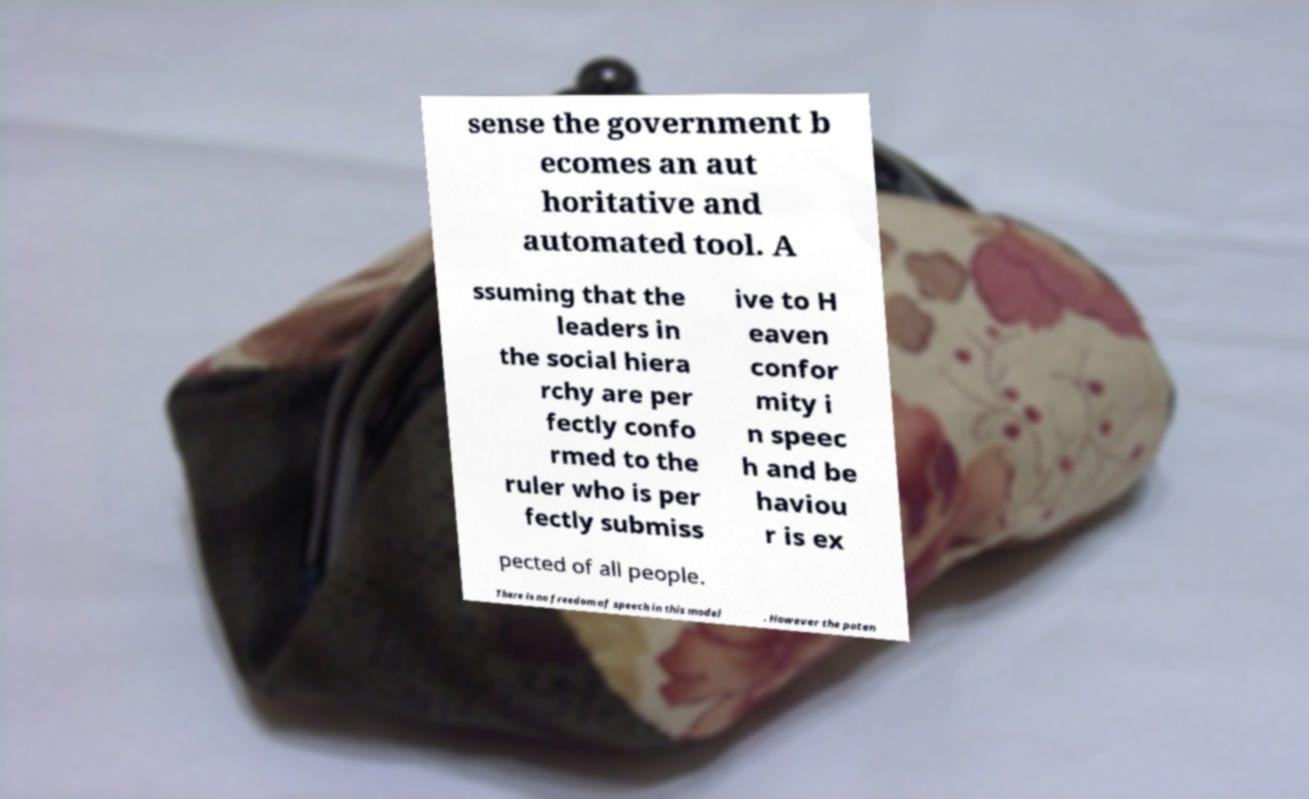Could you assist in decoding the text presented in this image and type it out clearly? sense the government b ecomes an aut horitative and automated tool. A ssuming that the leaders in the social hiera rchy are per fectly confo rmed to the ruler who is per fectly submiss ive to H eaven confor mity i n speec h and be haviou r is ex pected of all people. There is no freedom of speech in this model . However the poten 